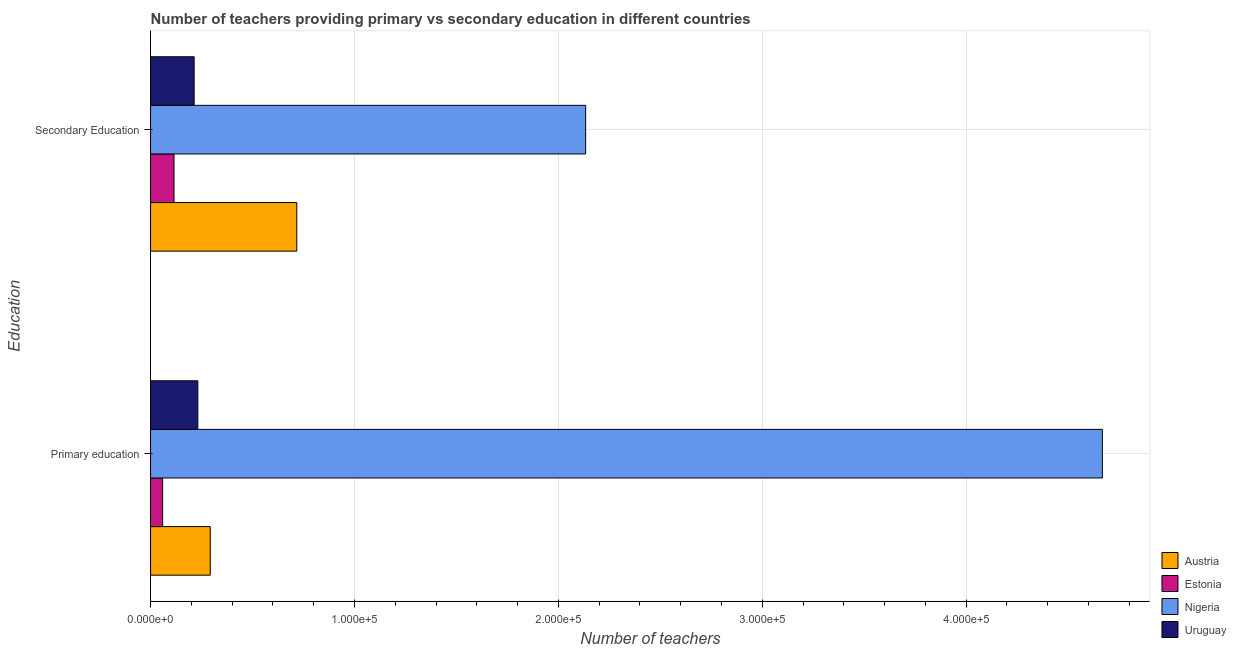Are the number of bars on each tick of the Y-axis equal?
Keep it short and to the point. Yes. What is the label of the 1st group of bars from the top?
Offer a terse response. Secondary Education. What is the number of secondary teachers in Nigeria?
Your response must be concise. 2.13e+05. Across all countries, what is the maximum number of secondary teachers?
Your answer should be compact. 2.13e+05. Across all countries, what is the minimum number of primary teachers?
Provide a short and direct response. 5927. In which country was the number of primary teachers maximum?
Give a very brief answer. Nigeria. In which country was the number of primary teachers minimum?
Provide a succinct answer. Estonia. What is the total number of secondary teachers in the graph?
Give a very brief answer. 3.18e+05. What is the difference between the number of primary teachers in Uruguay and that in Nigeria?
Provide a short and direct response. -4.44e+05. What is the difference between the number of secondary teachers in Nigeria and the number of primary teachers in Uruguay?
Make the answer very short. 1.90e+05. What is the average number of primary teachers per country?
Provide a short and direct response. 1.31e+05. What is the difference between the number of secondary teachers and number of primary teachers in Uruguay?
Provide a succinct answer. -1806. What is the ratio of the number of primary teachers in Nigeria to that in Uruguay?
Offer a very short reply. 20.14. In how many countries, is the number of primary teachers greater than the average number of primary teachers taken over all countries?
Give a very brief answer. 1. What does the 1st bar from the top in Secondary Education represents?
Make the answer very short. Uruguay. How many bars are there?
Give a very brief answer. 8. Are all the bars in the graph horizontal?
Offer a very short reply. Yes. What is the difference between two consecutive major ticks on the X-axis?
Your answer should be very brief. 1.00e+05. Does the graph contain any zero values?
Your answer should be compact. No. Does the graph contain grids?
Your response must be concise. Yes. Where does the legend appear in the graph?
Give a very brief answer. Bottom right. How many legend labels are there?
Offer a terse response. 4. How are the legend labels stacked?
Your answer should be very brief. Vertical. What is the title of the graph?
Offer a very short reply. Number of teachers providing primary vs secondary education in different countries. Does "Luxembourg" appear as one of the legend labels in the graph?
Make the answer very short. No. What is the label or title of the X-axis?
Make the answer very short. Number of teachers. What is the label or title of the Y-axis?
Provide a succinct answer. Education. What is the Number of teachers in Austria in Primary education?
Offer a very short reply. 2.93e+04. What is the Number of teachers of Estonia in Primary education?
Your response must be concise. 5927. What is the Number of teachers in Nigeria in Primary education?
Make the answer very short. 4.67e+05. What is the Number of teachers in Uruguay in Primary education?
Provide a short and direct response. 2.32e+04. What is the Number of teachers of Austria in Secondary Education?
Your response must be concise. 7.17e+04. What is the Number of teachers of Estonia in Secondary Education?
Ensure brevity in your answer.  1.15e+04. What is the Number of teachers of Nigeria in Secondary Education?
Give a very brief answer. 2.13e+05. What is the Number of teachers in Uruguay in Secondary Education?
Make the answer very short. 2.14e+04. Across all Education, what is the maximum Number of teachers in Austria?
Make the answer very short. 7.17e+04. Across all Education, what is the maximum Number of teachers in Estonia?
Make the answer very short. 1.15e+04. Across all Education, what is the maximum Number of teachers of Nigeria?
Your answer should be very brief. 4.67e+05. Across all Education, what is the maximum Number of teachers of Uruguay?
Offer a very short reply. 2.32e+04. Across all Education, what is the minimum Number of teachers of Austria?
Your response must be concise. 2.93e+04. Across all Education, what is the minimum Number of teachers in Estonia?
Your response must be concise. 5927. Across all Education, what is the minimum Number of teachers of Nigeria?
Provide a short and direct response. 2.13e+05. Across all Education, what is the minimum Number of teachers of Uruguay?
Your answer should be compact. 2.14e+04. What is the total Number of teachers of Austria in the graph?
Your answer should be very brief. 1.01e+05. What is the total Number of teachers of Estonia in the graph?
Your answer should be compact. 1.74e+04. What is the total Number of teachers in Nigeria in the graph?
Offer a terse response. 6.80e+05. What is the total Number of teachers of Uruguay in the graph?
Offer a terse response. 4.45e+04. What is the difference between the Number of teachers in Austria in Primary education and that in Secondary Education?
Your response must be concise. -4.24e+04. What is the difference between the Number of teachers in Estonia in Primary education and that in Secondary Education?
Provide a succinct answer. -5569. What is the difference between the Number of teachers in Nigeria in Primary education and that in Secondary Education?
Your answer should be compact. 2.53e+05. What is the difference between the Number of teachers of Uruguay in Primary education and that in Secondary Education?
Give a very brief answer. 1806. What is the difference between the Number of teachers in Austria in Primary education and the Number of teachers in Estonia in Secondary Education?
Offer a very short reply. 1.78e+04. What is the difference between the Number of teachers in Austria in Primary education and the Number of teachers in Nigeria in Secondary Education?
Keep it short and to the point. -1.84e+05. What is the difference between the Number of teachers of Austria in Primary education and the Number of teachers of Uruguay in Secondary Education?
Your response must be concise. 7905. What is the difference between the Number of teachers in Estonia in Primary education and the Number of teachers in Nigeria in Secondary Education?
Offer a terse response. -2.07e+05. What is the difference between the Number of teachers of Estonia in Primary education and the Number of teachers of Uruguay in Secondary Education?
Provide a short and direct response. -1.54e+04. What is the difference between the Number of teachers in Nigeria in Primary education and the Number of teachers in Uruguay in Secondary Education?
Ensure brevity in your answer.  4.45e+05. What is the average Number of teachers in Austria per Education?
Your answer should be compact. 5.05e+04. What is the average Number of teachers in Estonia per Education?
Make the answer very short. 8711.5. What is the average Number of teachers in Nigeria per Education?
Your answer should be very brief. 3.40e+05. What is the average Number of teachers of Uruguay per Education?
Offer a terse response. 2.23e+04. What is the difference between the Number of teachers of Austria and Number of teachers of Estonia in Primary education?
Your answer should be compact. 2.33e+04. What is the difference between the Number of teachers of Austria and Number of teachers of Nigeria in Primary education?
Your answer should be compact. -4.38e+05. What is the difference between the Number of teachers of Austria and Number of teachers of Uruguay in Primary education?
Your response must be concise. 6099. What is the difference between the Number of teachers of Estonia and Number of teachers of Nigeria in Primary education?
Keep it short and to the point. -4.61e+05. What is the difference between the Number of teachers in Estonia and Number of teachers in Uruguay in Primary education?
Provide a succinct answer. -1.72e+04. What is the difference between the Number of teachers of Nigeria and Number of teachers of Uruguay in Primary education?
Ensure brevity in your answer.  4.44e+05. What is the difference between the Number of teachers in Austria and Number of teachers in Estonia in Secondary Education?
Provide a short and direct response. 6.02e+04. What is the difference between the Number of teachers in Austria and Number of teachers in Nigeria in Secondary Education?
Make the answer very short. -1.42e+05. What is the difference between the Number of teachers in Austria and Number of teachers in Uruguay in Secondary Education?
Your response must be concise. 5.03e+04. What is the difference between the Number of teachers of Estonia and Number of teachers of Nigeria in Secondary Education?
Ensure brevity in your answer.  -2.02e+05. What is the difference between the Number of teachers in Estonia and Number of teachers in Uruguay in Secondary Education?
Ensure brevity in your answer.  -9873. What is the difference between the Number of teachers of Nigeria and Number of teachers of Uruguay in Secondary Education?
Your answer should be very brief. 1.92e+05. What is the ratio of the Number of teachers of Austria in Primary education to that in Secondary Education?
Provide a short and direct response. 0.41. What is the ratio of the Number of teachers of Estonia in Primary education to that in Secondary Education?
Offer a terse response. 0.52. What is the ratio of the Number of teachers of Nigeria in Primary education to that in Secondary Education?
Your response must be concise. 2.19. What is the ratio of the Number of teachers in Uruguay in Primary education to that in Secondary Education?
Give a very brief answer. 1.08. What is the difference between the highest and the second highest Number of teachers in Austria?
Offer a very short reply. 4.24e+04. What is the difference between the highest and the second highest Number of teachers of Estonia?
Provide a short and direct response. 5569. What is the difference between the highest and the second highest Number of teachers of Nigeria?
Offer a terse response. 2.53e+05. What is the difference between the highest and the second highest Number of teachers in Uruguay?
Offer a very short reply. 1806. What is the difference between the highest and the lowest Number of teachers of Austria?
Your response must be concise. 4.24e+04. What is the difference between the highest and the lowest Number of teachers in Estonia?
Your response must be concise. 5569. What is the difference between the highest and the lowest Number of teachers in Nigeria?
Make the answer very short. 2.53e+05. What is the difference between the highest and the lowest Number of teachers of Uruguay?
Keep it short and to the point. 1806. 